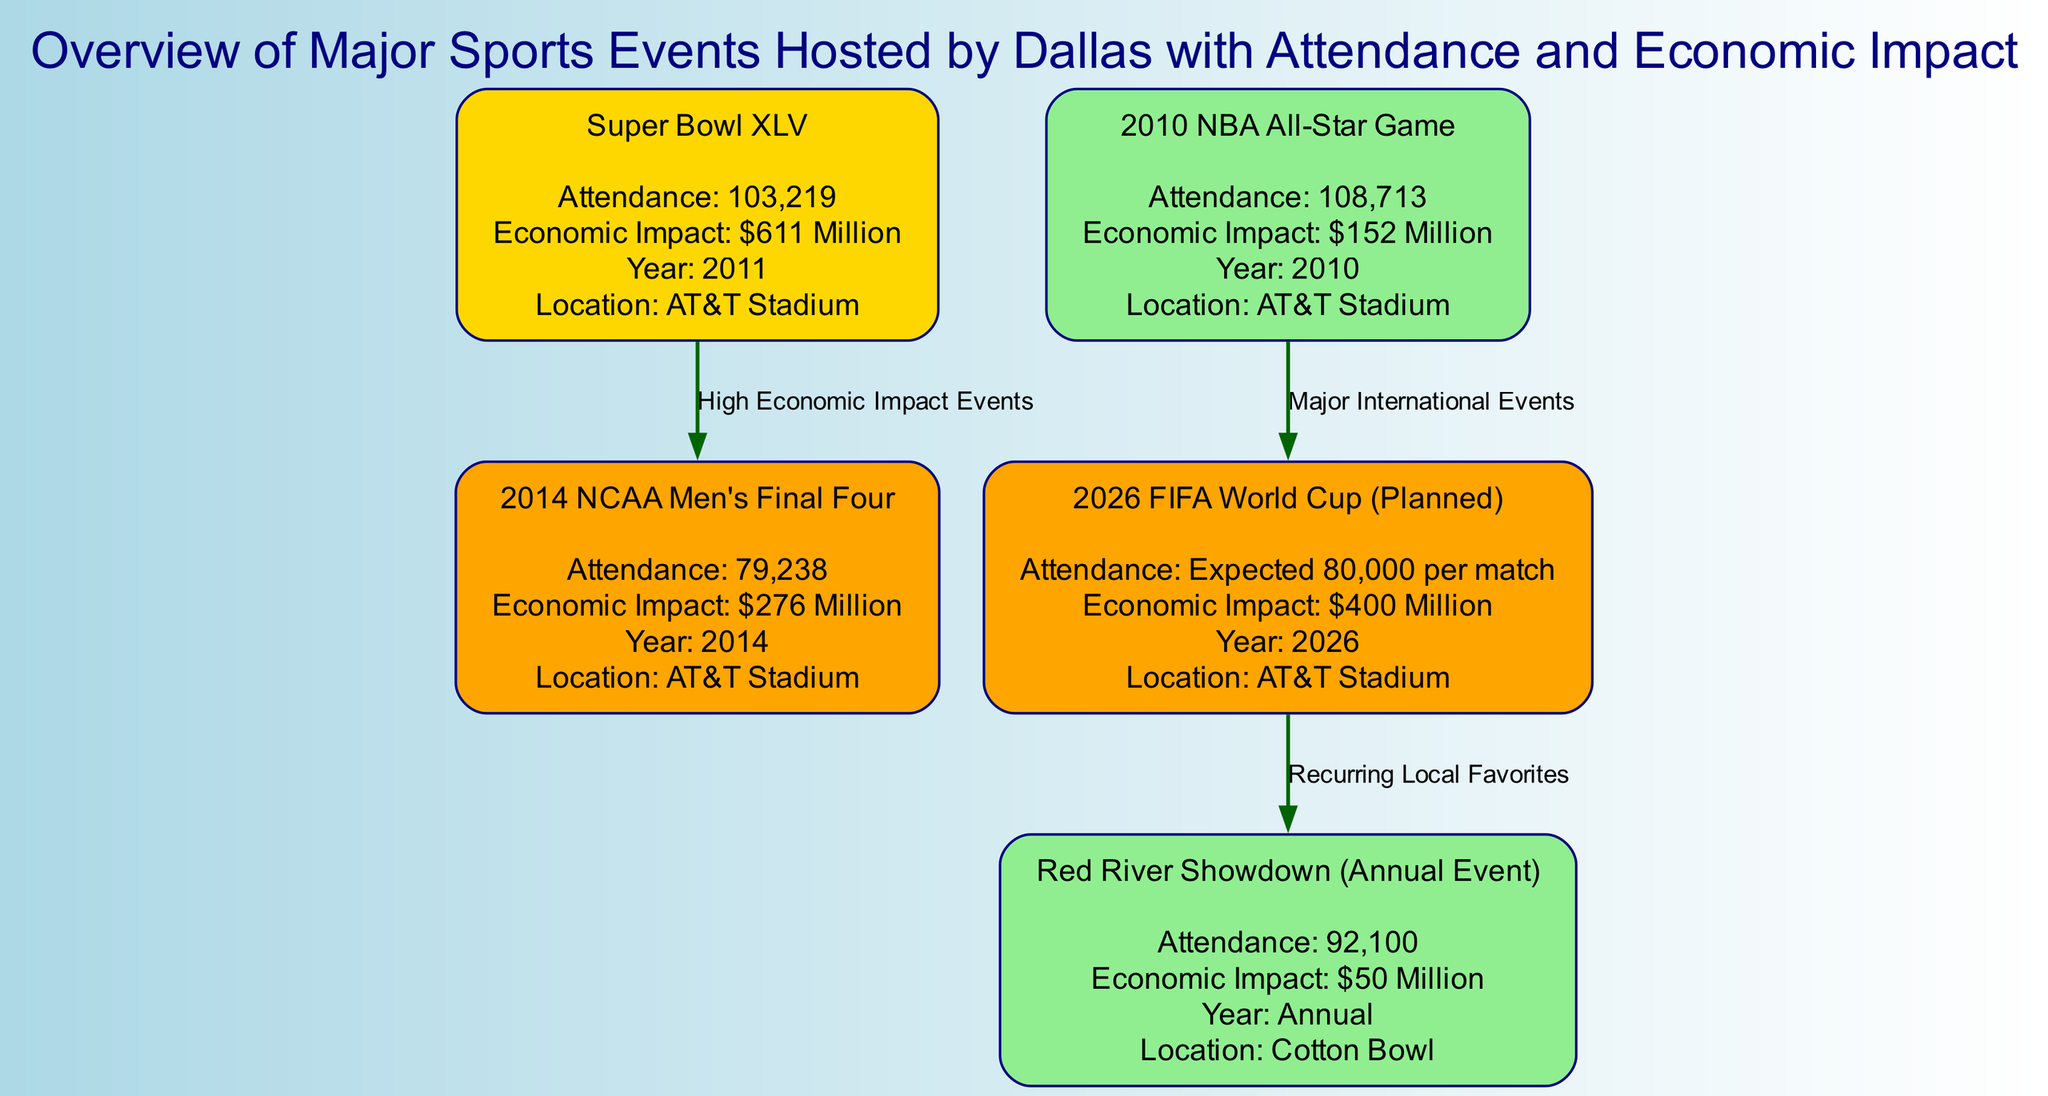What is the attendance for Super Bowl XLV? The diagram indicates that Super Bowl XLV had an attendance of 103,219. This information is found directly under the event label in the node for Super Bowl XLV.
Answer: 103,219 What was the economic impact of the 2014 NCAA Men's Final Four? The diagram states that the economic impact of the 2014 NCAA Men's Final Four was $276 Million, which can be seen in the details section of that specific event node.
Answer: $276 Million Which location hosted the 2010 NBA All-Star Game? According to the details provided in the node for the 2010 NBA All-Star Game, it was hosted at AT&T Stadium. This is explicitly stated in the event's location detail.
Answer: AT&T Stadium How many nodes are represented in the diagram? The diagram lists a total of 5 nodes that correspond to different sporting events, including the Super Bowl and NCAA tournaments. This can be counted from the list of nodes provided.
Answer: 5 What is the relationship between the 2026 FIFA World Cup and the Red River Showdown? The diagram shows that the 2026 FIFA World Cup (planned) leads to the Red River Showdown as a recurring local favorite, indicated by the directed edge labeled “Recurring Local Favorites.” This implies that the FIFA World Cup highlights significant events that support annual occurrences like the Red River Showdown.
Answer: Recurring Local Favorites What is the expected attendance for the 2026 FIFA World Cup? The diagram mentions that the expected attendance per match for the 2026 FIFA World Cup is 80,000, as noted in the attendance details of that event node.
Answer: Expected 80,000 per match Which event had the highest economic impact and what was its value? Upon reviewing the diagram, Super Bowl XLV had the highest economic impact of $611 Million, as indicated in its detail section. This is the largest figure when comparing the economic impacts of all listed events.
Answer: $611 Million What type of events does the edge labeled "Major International Events" connect? The edge labeled "Major International Events" connects the 2010 NBA All-Star Game and the 2026 FIFA World Cup, highlighting a relationship between these two significant, large-scale sporting events in the diagram.
Answer: 2010 NBA All-Star Game and 2026 FIFA World Cup What economic impact value is associated with the Red River Showdown? The economic impact value associated with the Red River Showdown is $50 Million, which is directly provided in the details of that specific event node.
Answer: $50 Million 